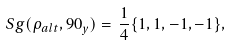<formula> <loc_0><loc_0><loc_500><loc_500>S g ( \rho _ { a l t } , 9 0 _ { y } ) = \, \frac { 1 } { 4 } \{ 1 , 1 , - 1 , - 1 \} ,</formula> 